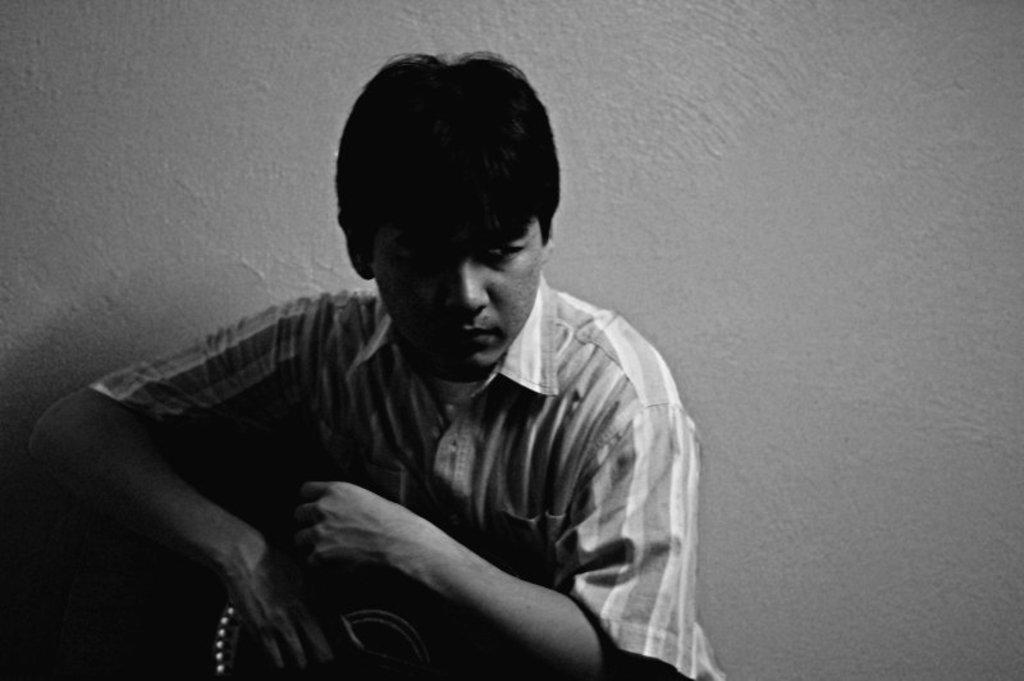How would you summarize this image in a sentence or two? In this image there is a man holding an object in his hand. In the background there is a wall. 